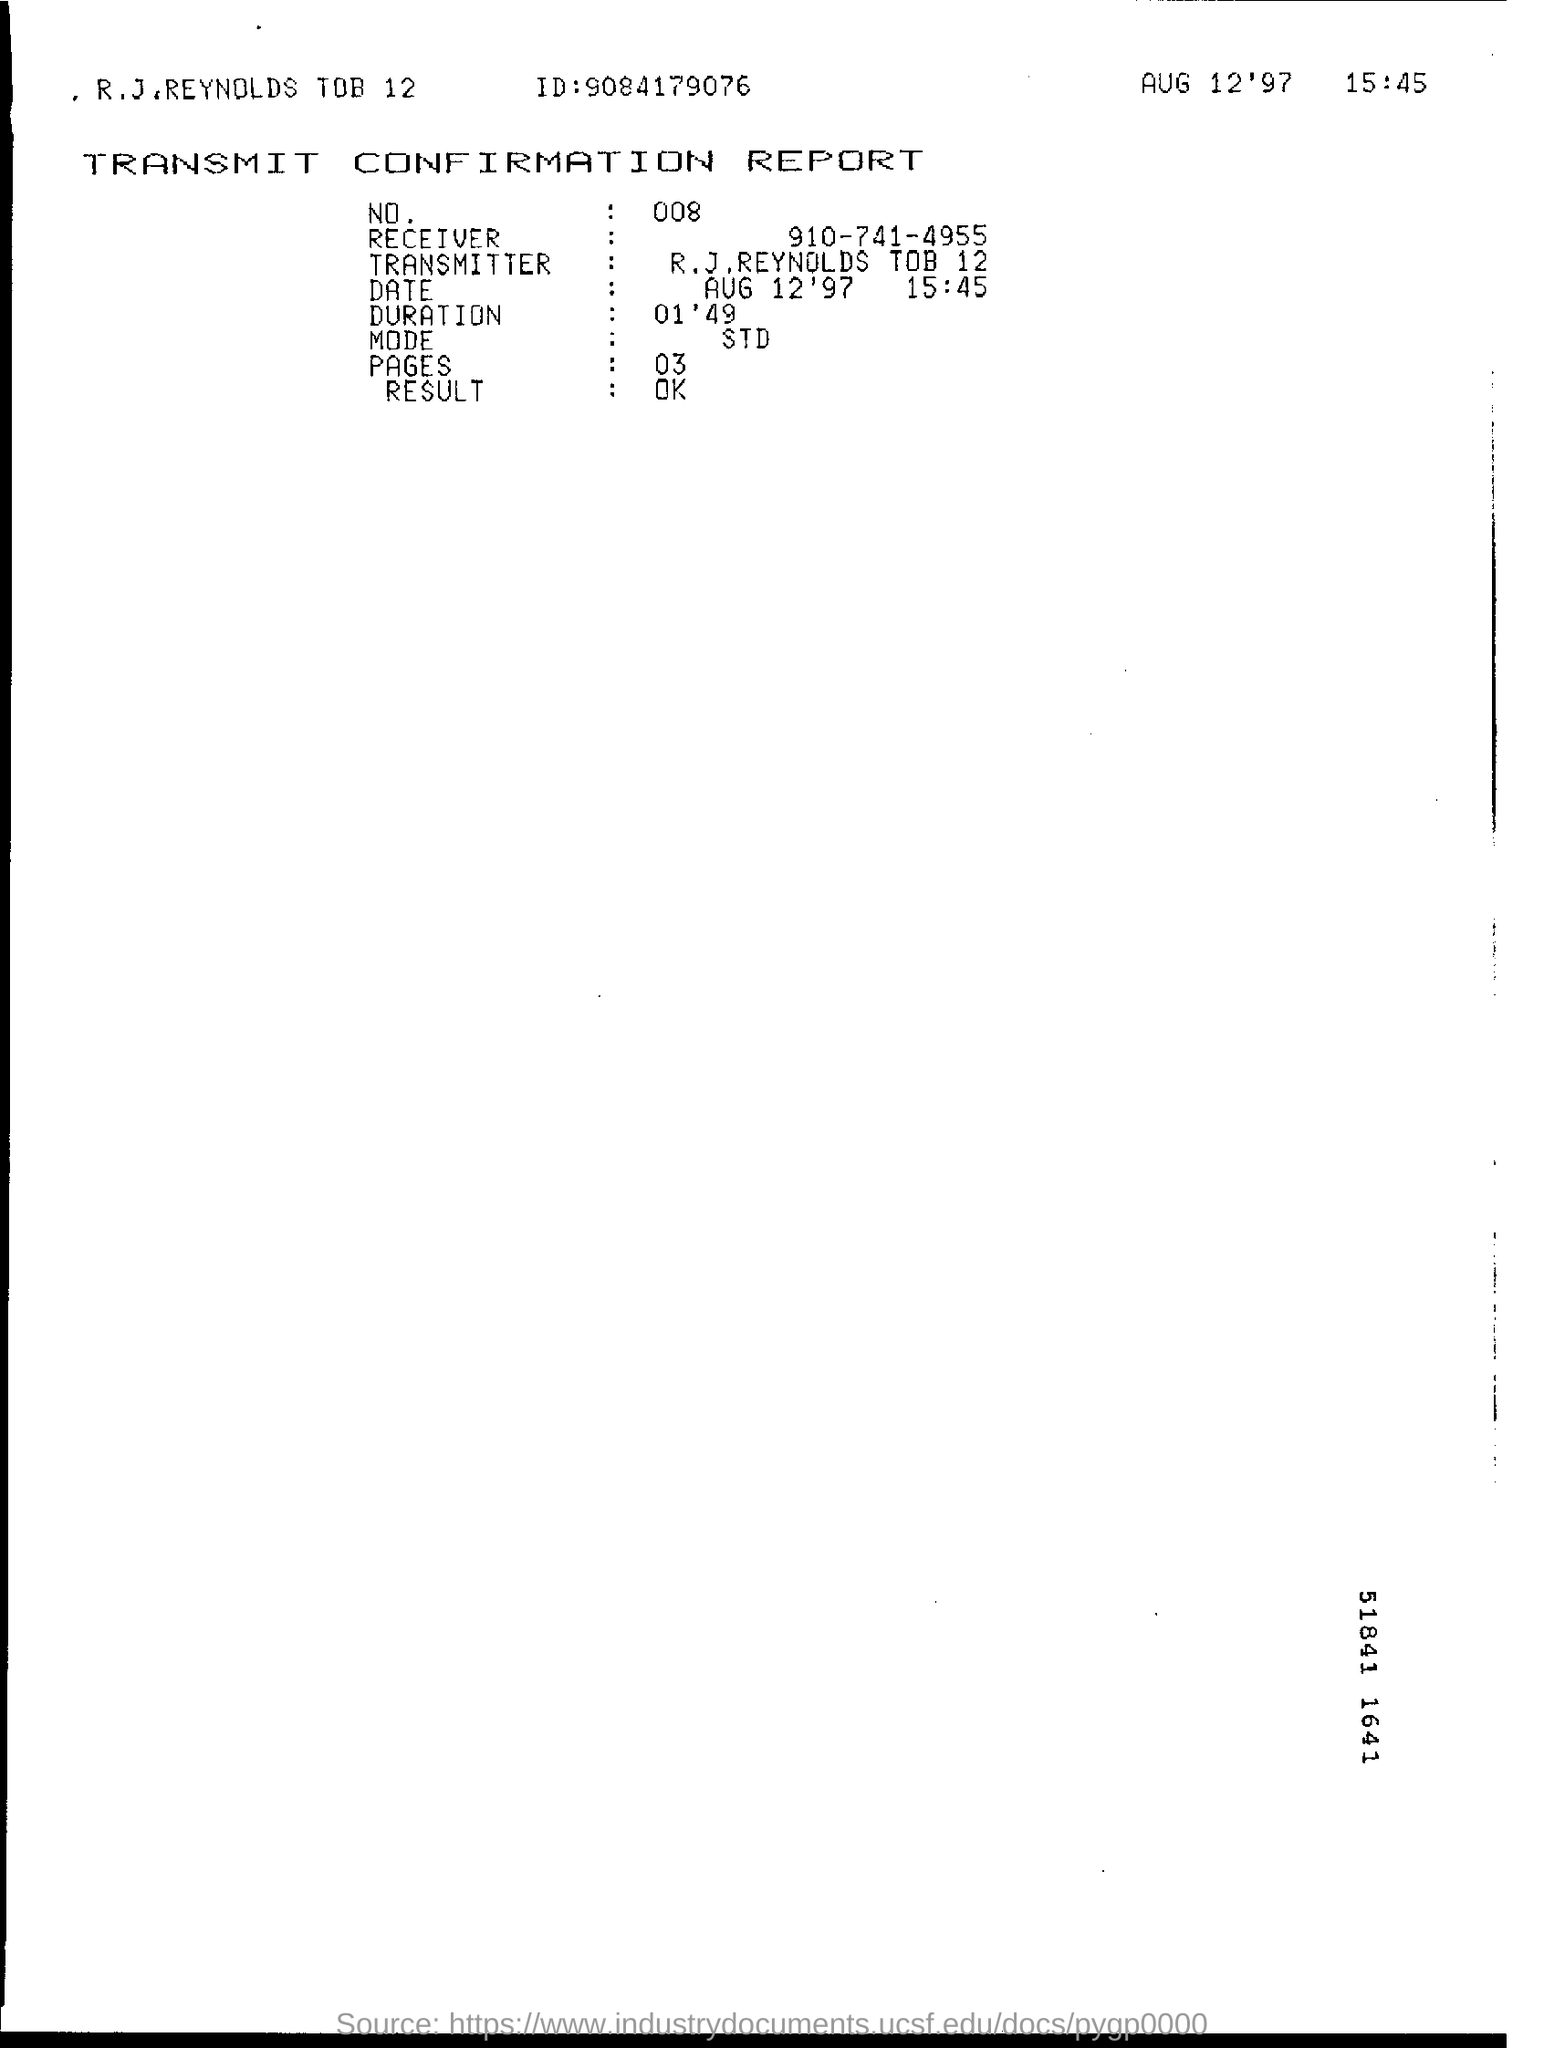What is the no. mentioned in the transmit confirmation report?
Provide a short and direct response. 008. What is the ID mentioned in the transmit confirmation report?
Ensure brevity in your answer.  9084179076. What is the duration mentioned in the transmit confirmation report?
Give a very brief answer. 01'49. What is the date & time of the fax transmission?
Your response must be concise. Aug 12'97 15:45. 